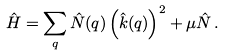Convert formula to latex. <formula><loc_0><loc_0><loc_500><loc_500>\hat { H } = \sum _ { q } \hat { N } ( q ) \left ( \hat { k } ( q ) \right ) ^ { 2 } + \mu \hat { N } \, .</formula> 